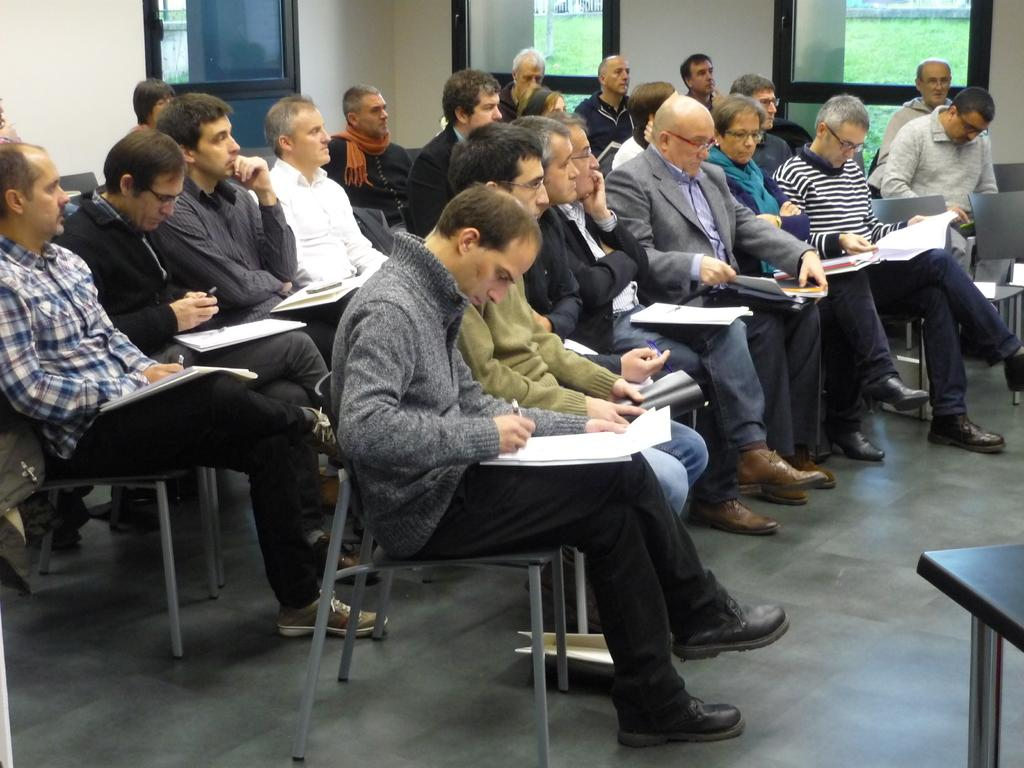What are the people in the image doing while sitting on chairs? Each person in the image holds a paper and a book. Is there any activity related to writing in the image? Yes, one person in the image is writing on a paper. What can be seen through the window in the image? The provided facts do not mention anything visible through the window. What is the color of the grass visible in the image? The grass visible in the image is green. How many wings can be seen on the picture in the image? There is no picture with wings present in the image. What type of room is depicted in the image? The provided facts do not mention the type of room or any architectural features. 